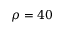<formula> <loc_0><loc_0><loc_500><loc_500>\rho = 4 0</formula> 